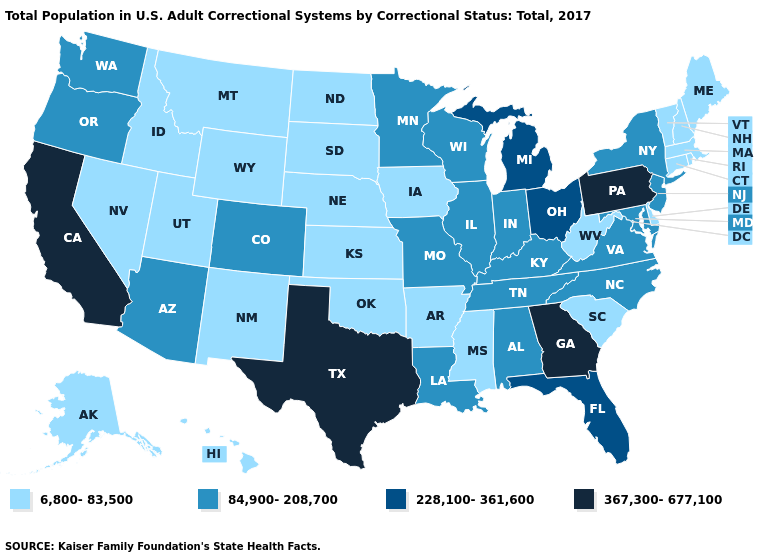Which states have the lowest value in the USA?
Quick response, please. Alaska, Arkansas, Connecticut, Delaware, Hawaii, Idaho, Iowa, Kansas, Maine, Massachusetts, Mississippi, Montana, Nebraska, Nevada, New Hampshire, New Mexico, North Dakota, Oklahoma, Rhode Island, South Carolina, South Dakota, Utah, Vermont, West Virginia, Wyoming. What is the value of Wisconsin?
Concise answer only. 84,900-208,700. Is the legend a continuous bar?
Short answer required. No. Which states have the lowest value in the MidWest?
Quick response, please. Iowa, Kansas, Nebraska, North Dakota, South Dakota. What is the value of Hawaii?
Be succinct. 6,800-83,500. What is the lowest value in the USA?
Short answer required. 6,800-83,500. What is the value of South Dakota?
Write a very short answer. 6,800-83,500. What is the value of Oregon?
Quick response, please. 84,900-208,700. Does Connecticut have the highest value in the USA?
Answer briefly. No. What is the value of Oregon?
Quick response, please. 84,900-208,700. Which states have the highest value in the USA?
Give a very brief answer. California, Georgia, Pennsylvania, Texas. Does Wisconsin have the same value as Utah?
Write a very short answer. No. What is the highest value in the MidWest ?
Give a very brief answer. 228,100-361,600. Among the states that border New Jersey , does Pennsylvania have the highest value?
Write a very short answer. Yes. Among the states that border Connecticut , does New York have the lowest value?
Be succinct. No. 